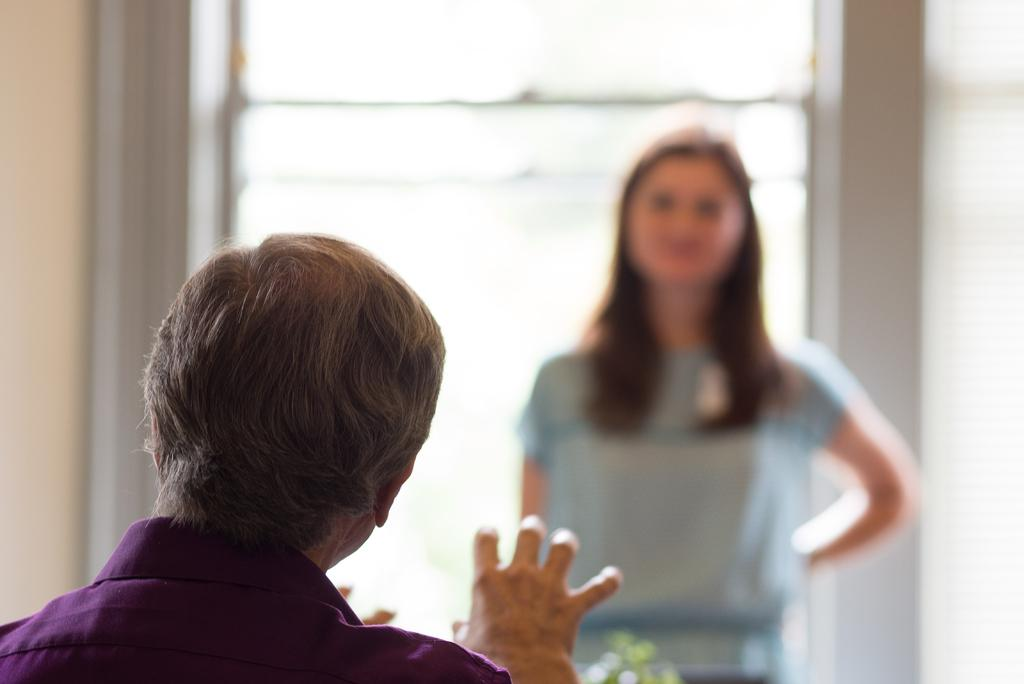How many people are in the image? There are two persons in the image. What can be observed about the background of the image? The background is blurred. What object is visible in the image that is typically used for holding liquids? There is a glass in the image. What type of structure can be seen in the image? There is a wall in the image. What is the range of the representative's speech in the image? There is no representative or speech present in the image, so it is not possible to determine the range of a speech. 